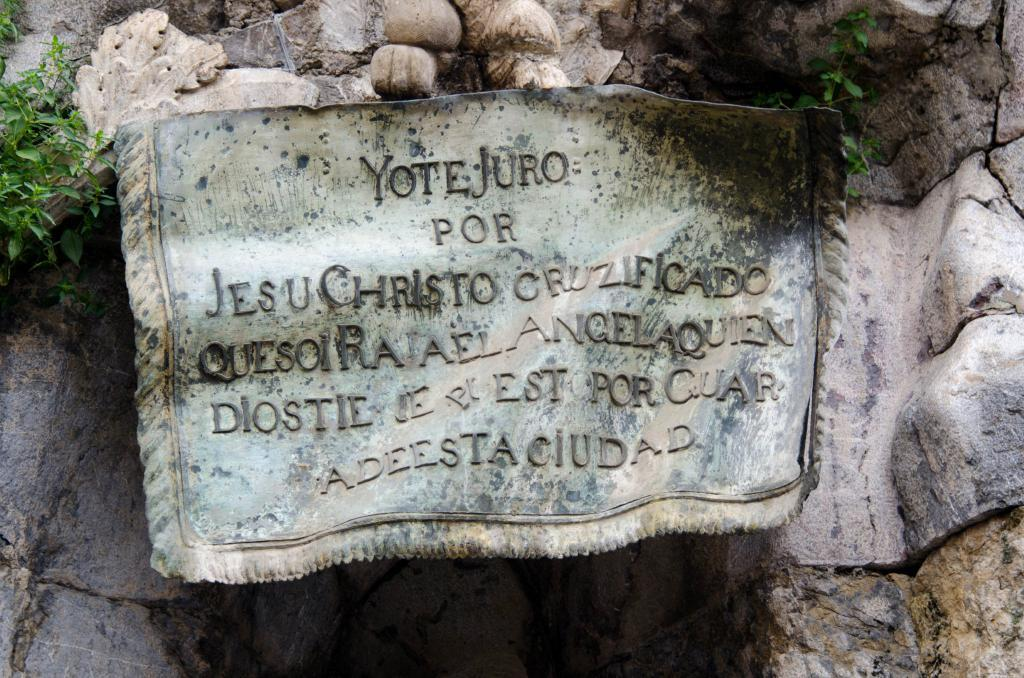What type of living organisms can be seen in the image? Plants can be seen in the image. What type of natural formation is present in the image? There are rocks in the image. Is there any text visible in the image? Yes, there is some text visible in the image. How many cobwebs can be seen in the image? There are no cobwebs present in the image. What type of pin is holding the plants in the image? There is no pin present in the image, and the plants are not being held by any pin. 